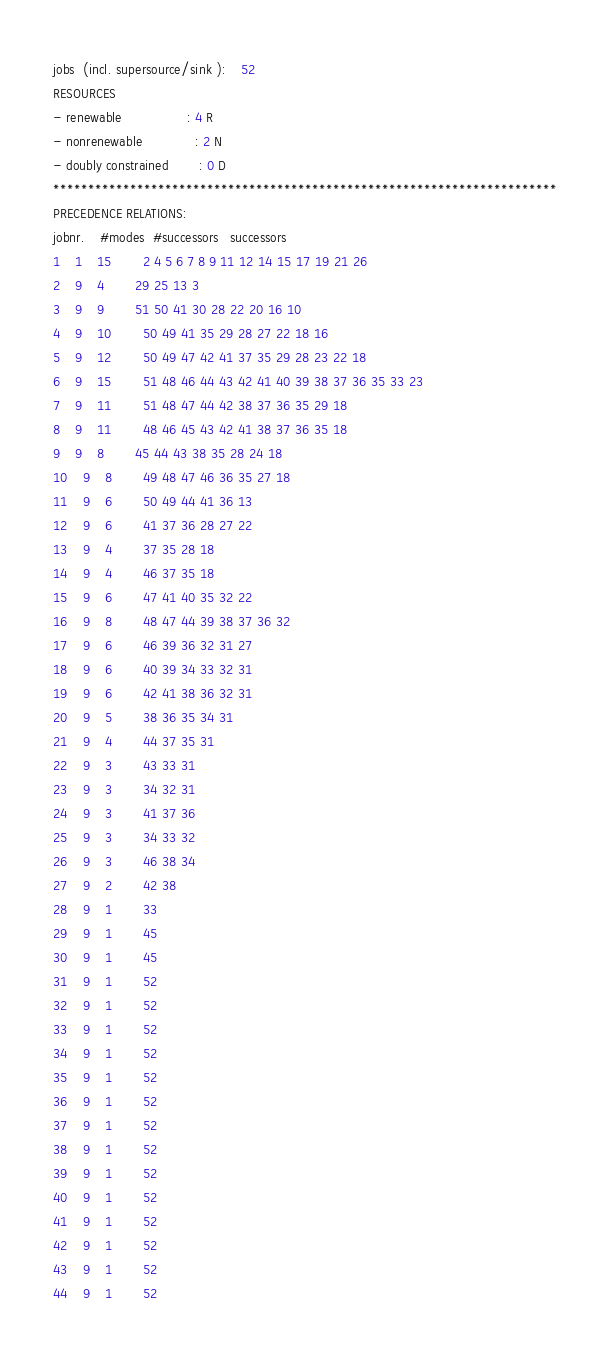Convert code to text. <code><loc_0><loc_0><loc_500><loc_500><_ObjectiveC_>jobs  (incl. supersource/sink ):	52
RESOURCES
- renewable                 : 4 R
- nonrenewable              : 2 N
- doubly constrained        : 0 D
************************************************************************
PRECEDENCE RELATIONS:
jobnr.    #modes  #successors   successors
1	1	15		2 4 5 6 7 8 9 11 12 14 15 17 19 21 26 
2	9	4		29 25 13 3 
3	9	9		51 50 41 30 28 22 20 16 10 
4	9	10		50 49 41 35 29 28 27 22 18 16 
5	9	12		50 49 47 42 41 37 35 29 28 23 22 18 
6	9	15		51 48 46 44 43 42 41 40 39 38 37 36 35 33 23 
7	9	11		51 48 47 44 42 38 37 36 35 29 18 
8	9	11		48 46 45 43 42 41 38 37 36 35 18 
9	9	8		45 44 43 38 35 28 24 18 
10	9	8		49 48 47 46 36 35 27 18 
11	9	6		50 49 44 41 36 13 
12	9	6		41 37 36 28 27 22 
13	9	4		37 35 28 18 
14	9	4		46 37 35 18 
15	9	6		47 41 40 35 32 22 
16	9	8		48 47 44 39 38 37 36 32 
17	9	6		46 39 36 32 31 27 
18	9	6		40 39 34 33 32 31 
19	9	6		42 41 38 36 32 31 
20	9	5		38 36 35 34 31 
21	9	4		44 37 35 31 
22	9	3		43 33 31 
23	9	3		34 32 31 
24	9	3		41 37 36 
25	9	3		34 33 32 
26	9	3		46 38 34 
27	9	2		42 38 
28	9	1		33 
29	9	1		45 
30	9	1		45 
31	9	1		52 
32	9	1		52 
33	9	1		52 
34	9	1		52 
35	9	1		52 
36	9	1		52 
37	9	1		52 
38	9	1		52 
39	9	1		52 
40	9	1		52 
41	9	1		52 
42	9	1		52 
43	9	1		52 
44	9	1		52 </code> 